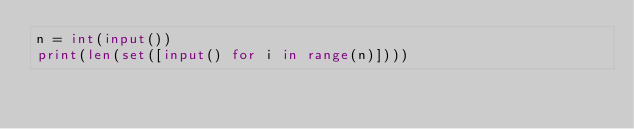Convert code to text. <code><loc_0><loc_0><loc_500><loc_500><_Python_>n = int(input())
print(len(set([input() for i in range(n)])))</code> 